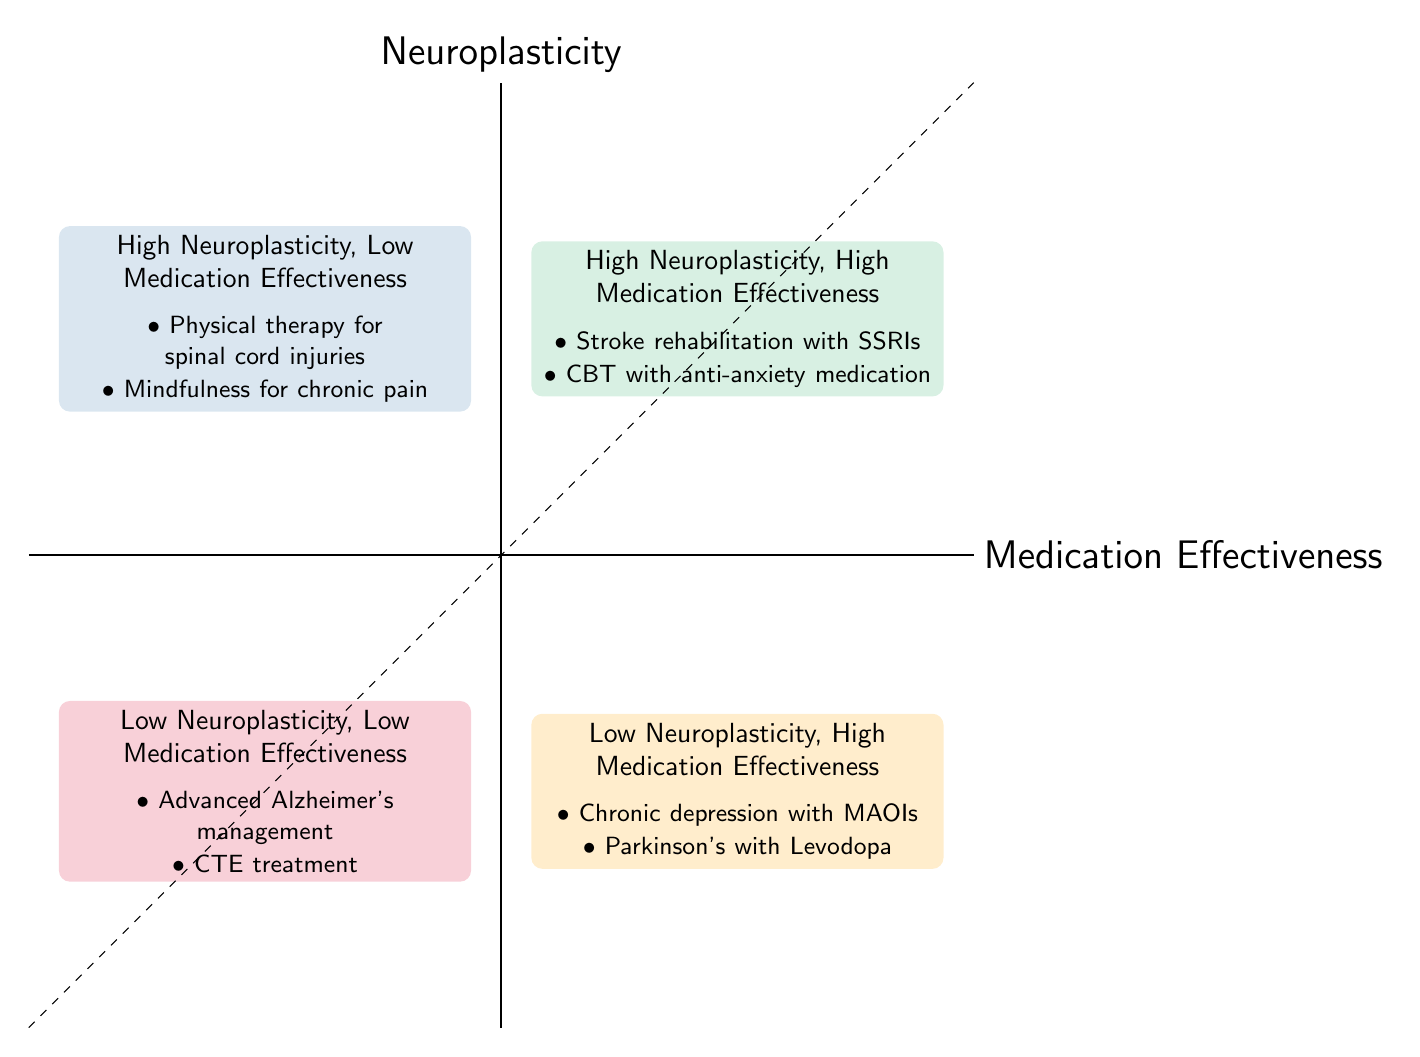What is in the High Neuroplasticity, High Medication Effectiveness quadrant? The quadrant contains examples such as "Stroke rehabilitation with SSRIs" and "Cognitive-behavioral therapy combined with anti-anxiety medication." I locate the High Neuroplasticity, High Medication Effectiveness section and note the listed examples.
Answer: Stroke rehabilitation with SSRIs, Cognitive-behavioral therapy combined with anti-anxiety medication Which quadrant has Low Neuroplasticity and High Medication Effectiveness? The quadrant specifically identified with these characteristics is labeled "Low Neuroplasticity, High Medication Effectiveness." I find and view the corresponding section in the diagram.
Answer: Low Neuroplasticity, High Medication Effectiveness How many examples are listed in the High Neuroplasticity, Low Medication Effectiveness quadrant? This quadrant lists two examples: "Intensive physical therapy for spinal cord injuries" and "Mindfulness and meditation practices for chronic pain management." I count the examples provided in that quadrant.
Answer: 2 What type of conditions are found in the Low Neuroplasticity, Low Medication Effectiveness quadrant? This quadrant includes cases where both neural adaptability and medication are ineffective, specifically citing "Advanced Alzheimer's disease management" and "Chronic traumatic encephalopathy (CTE) treatment." I look at the examples to assess their nature.
Answer: Advanced Alzheimer's disease management, Chronic traumatic encephalopathy (CTE) treatment Why might Stroke rehabilitation with SSRIs be in the High Neuroplasticity, High Medication Effectiveness quadrant? Stroke rehabilitation often requires significant brain adaptability (neuroplasticity) for recovery, and combining this approach with SSRIs can enhance mood and cognitive function, making it a highly effective treatment. I analyze the relationship between neuroplasticity and medication effectiveness in this context.
Answer: Because both neuroplasticity and medication effectiveness are high What is the relationship between neuroplasticity and medication effectiveness in the Low Neuroplasticity, High Medication Effectiveness quadrant? In this quadrant, neural adaptation is limited, but medications are effective, indicating that while the body's ability to change is restricted, pharmacological treatments can still provide benefits. I examine the properties of the quadrant to describe this relationship.
Answer: Limited neuroplasticity, effective medications 